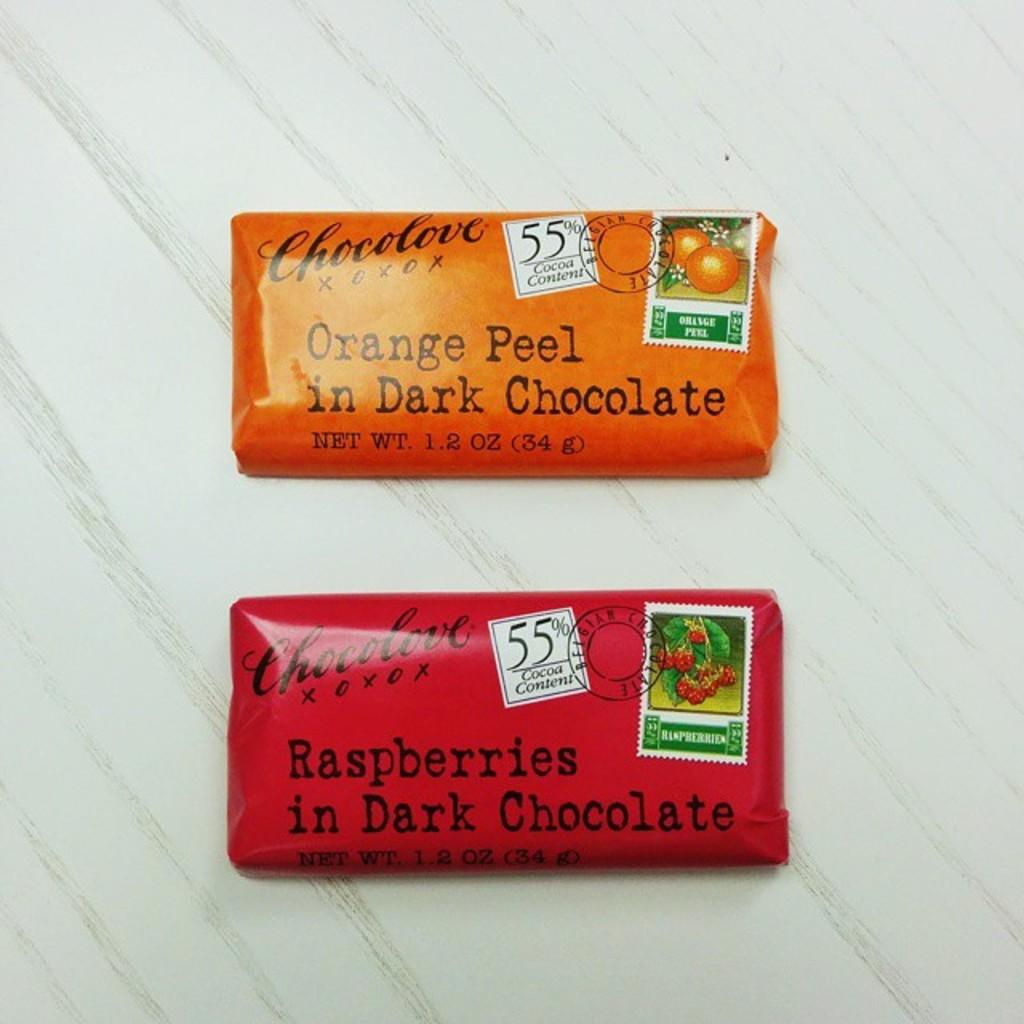<image>
Summarize the visual content of the image. 2 bars of chocolove, one is rasperries in dark chocolate and other is orange peel in dark chocolate 